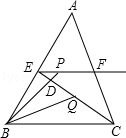What geometric properties can be observed by examining the triangle and its internal divisions? The image represents a triangle subdivided by points that create smaller triangles and line segments inside. Notably, it illustrates properties such as midpoint, similarity of triangles, and angle bisectors. This setup is often used in problems involving proofs and demonstrations in Euclidean geometry. 